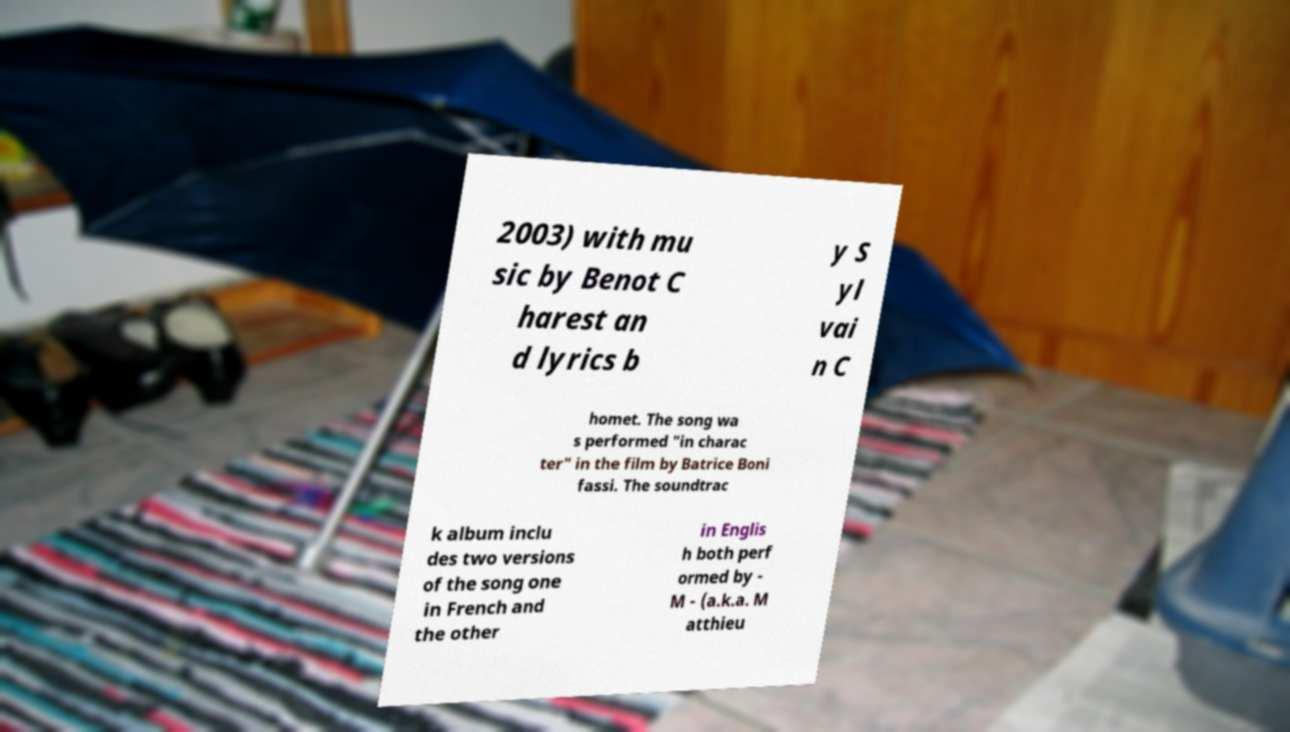Could you extract and type out the text from this image? 2003) with mu sic by Benot C harest an d lyrics b y S yl vai n C homet. The song wa s performed "in charac ter" in the film by Batrice Boni fassi. The soundtrac k album inclu des two versions of the song one in French and the other in Englis h both perf ormed by - M - (a.k.a. M atthieu 